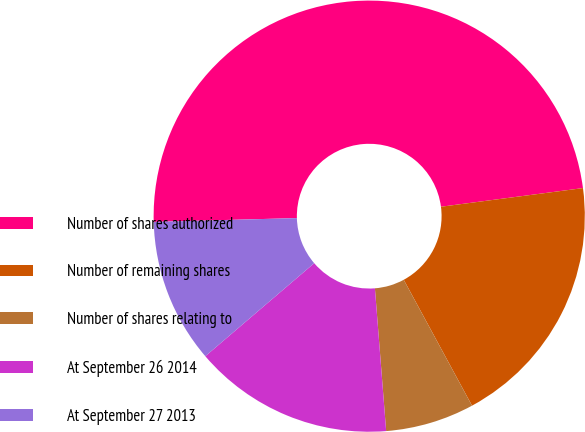Convert chart. <chart><loc_0><loc_0><loc_500><loc_500><pie_chart><fcel>Number of shares authorized<fcel>Number of remaining shares<fcel>Number of shares relating to<fcel>At September 26 2014<fcel>At September 27 2013<nl><fcel>48.35%<fcel>19.17%<fcel>6.66%<fcel>15.0%<fcel>10.83%<nl></chart> 